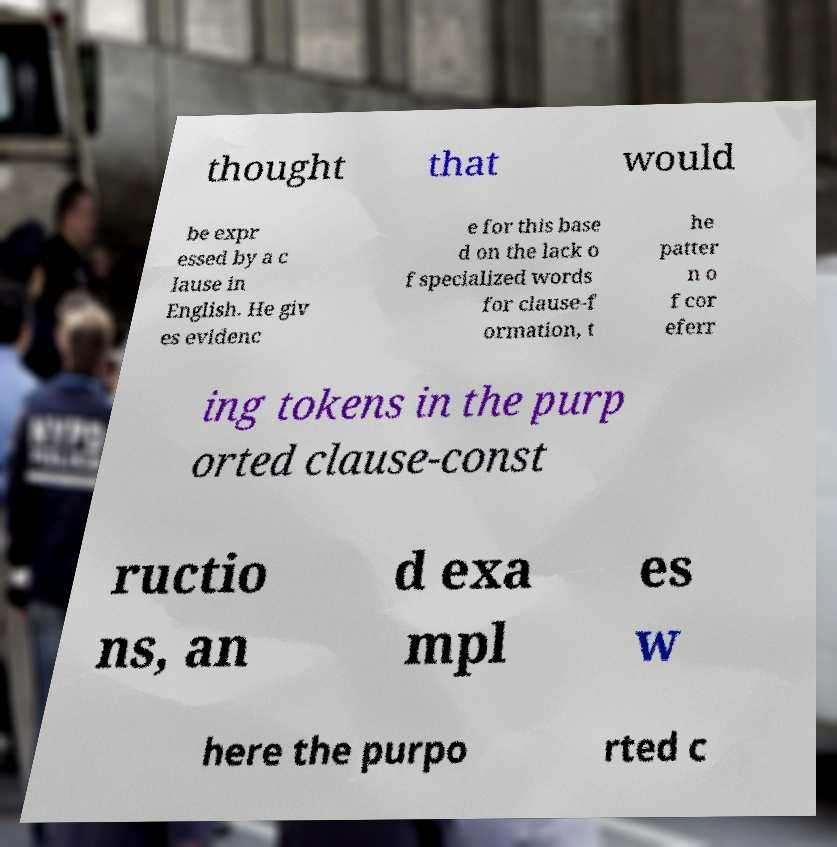Could you extract and type out the text from this image? thought that would be expr essed by a c lause in English. He giv es evidenc e for this base d on the lack o f specialized words for clause-f ormation, t he patter n o f cor eferr ing tokens in the purp orted clause-const ructio ns, an d exa mpl es w here the purpo rted c 